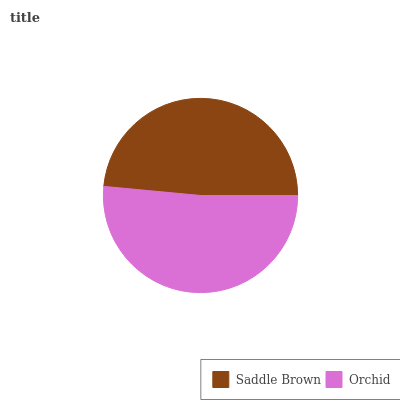Is Saddle Brown the minimum?
Answer yes or no. Yes. Is Orchid the maximum?
Answer yes or no. Yes. Is Orchid the minimum?
Answer yes or no. No. Is Orchid greater than Saddle Brown?
Answer yes or no. Yes. Is Saddle Brown less than Orchid?
Answer yes or no. Yes. Is Saddle Brown greater than Orchid?
Answer yes or no. No. Is Orchid less than Saddle Brown?
Answer yes or no. No. Is Orchid the high median?
Answer yes or no. Yes. Is Saddle Brown the low median?
Answer yes or no. Yes. Is Saddle Brown the high median?
Answer yes or no. No. Is Orchid the low median?
Answer yes or no. No. 